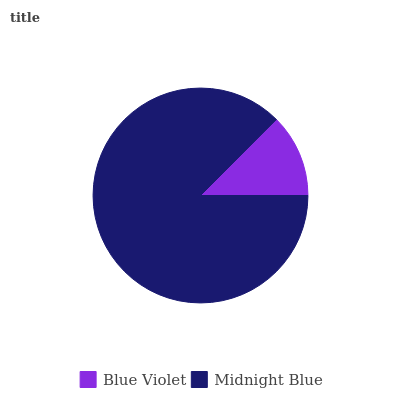Is Blue Violet the minimum?
Answer yes or no. Yes. Is Midnight Blue the maximum?
Answer yes or no. Yes. Is Midnight Blue the minimum?
Answer yes or no. No. Is Midnight Blue greater than Blue Violet?
Answer yes or no. Yes. Is Blue Violet less than Midnight Blue?
Answer yes or no. Yes. Is Blue Violet greater than Midnight Blue?
Answer yes or no. No. Is Midnight Blue less than Blue Violet?
Answer yes or no. No. Is Midnight Blue the high median?
Answer yes or no. Yes. Is Blue Violet the low median?
Answer yes or no. Yes. Is Blue Violet the high median?
Answer yes or no. No. Is Midnight Blue the low median?
Answer yes or no. No. 